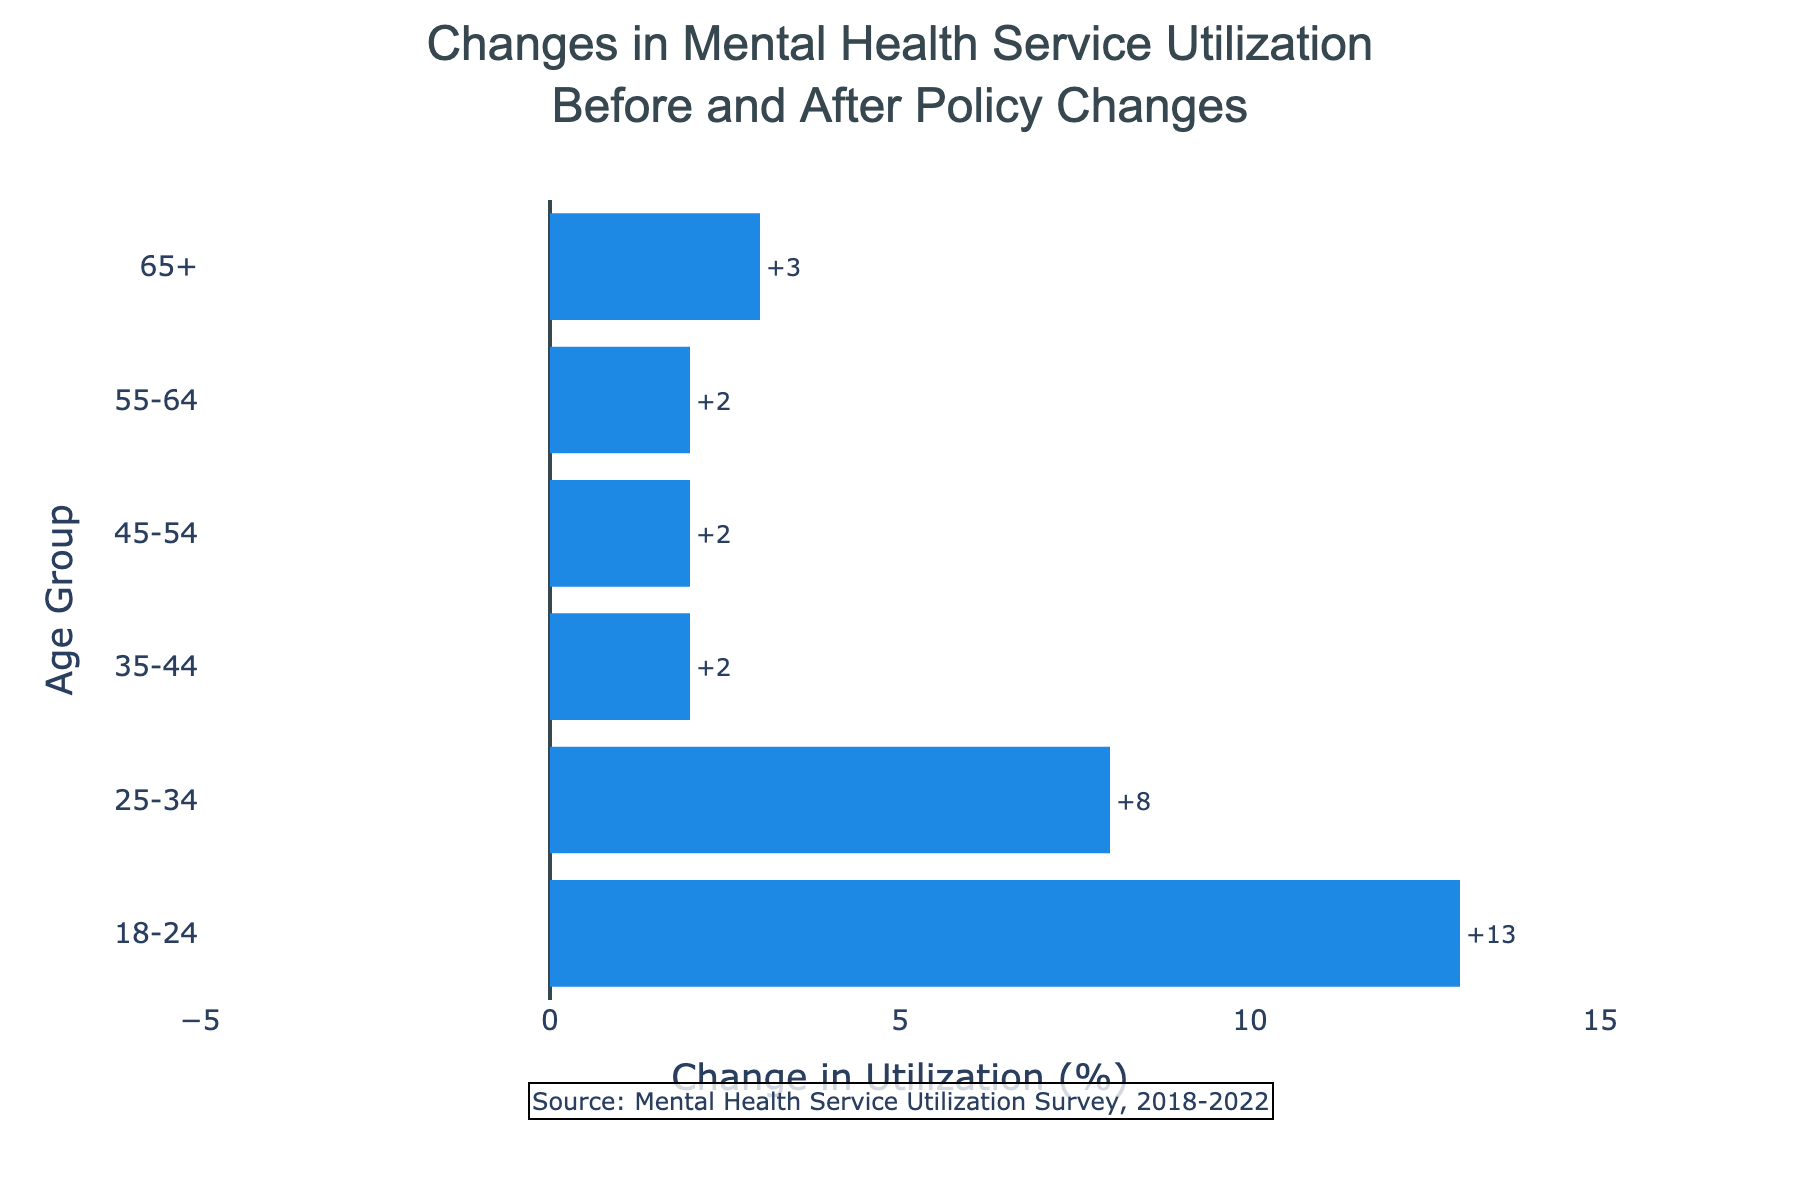Which age group saw the largest absolute increase in mental health service utilization? Compare the differences for each age group and identify the largest positive number. The increases are: 18-24 (13), 25-34 (8), 35-44 (2), 45-54 (2), 55-64 (2), 65+ (3). The largest increase is 13.
Answer: 18-24 Which age group had the smallest change in mental health service utilization? Compare the differences for each age group and identify the smallest number. The changes are: 18-24 (13), 25-34 (8), 35-44 (2), 45-54 (2), 55-64 (2), 65+ (3). The smallest change is 2.
Answer: 35-44, 45-54, 55-64 What is the total change in mental health service utilization across all age groups? Sum the differences for each age group: 13 + 8 + 2 + 2 + 2 + 3 = 30.
Answer: 30 What was the change in mental health service utilization for the 65+ age group? Look up the difference for the 65+ age group: 17 (2022) - 14 (2018) = 3.
Answer: 3 Which age groups experienced an increase in mental health service utilization? Identify which age groups have a positive difference. The age groups with positive differences are: 18-24, 25-34, 35-44, 45-54, 55-64, 65+.
Answer: 18-24, 25-34, 35-44, 45-54, 55-64, 65+ Which age group had the smallest increase in mental health service utilization? Compare the positive differences for each age group and identify the smallest positive number. The increases are: 18-24 (13), 25-34 (8), 35-44 (2), 45-54 (2), 55-64 (2), 65+ (3). The smallest increase is 2.
Answer: 35-44, 45-54, 55-64 What is the median change in mental health service utilization across all age groups? Arrange the differences in ascending order: 2, 2, 2, 3, 8, 13. Calculate the median: (2 + 3) / 2 = 2.5.
Answer: 2.5 By how much did the mental health service utilization for the 18-24 age group increase? Look up the difference for the 18-24 age group: 28 (2022) - 15 (2018) = 13.
Answer: 13 How many age groups experienced a change greater than 5% in mental health service utilization? Identify age groups with a difference greater than 5. The differences are: 13, 8, 2, 2, 2, 3. Age groups with differences greater than 5 are: 18-24, 25-34.
Answer: 2 